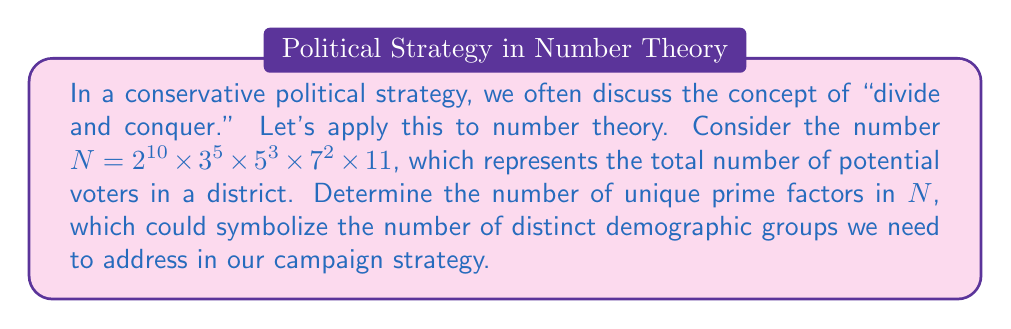Can you answer this question? To solve this problem, we need to identify the unique prime factors in the given number $N$. Let's break it down step-by-step:

1) First, let's recall the fundamental theorem of arithmetic, which states that every positive integer can be represented uniquely as a product of prime powers.

2) In our case, $N = 2^{10} \times 3^5 \times 5^3 \times 7^2 \times 11$

3) We can identify the prime factors from this representation:
   - $2$ is a prime factor
   - $3$ is a prime factor
   - $5$ is a prime factor
   - $7$ is a prime factor
   - $11$ is a prime factor

4) Note that the exponents (10, 5, 3, 2, and 1) indicate how many times each prime factor appears in the factorization, but they don't affect the count of unique prime factors.

5) Therefore, we simply need to count the number of distinct prime bases in this factorization.

6) We can see that there are 5 distinct prime bases: 2, 3, 5, 7, and 11.

In the context of our political analogy, this means we would need to tailor our campaign strategy to address 5 distinct demographic groups to effectively "divide and conquer" the voter base.
Answer: The number of unique prime factors in $N$ is 5. 